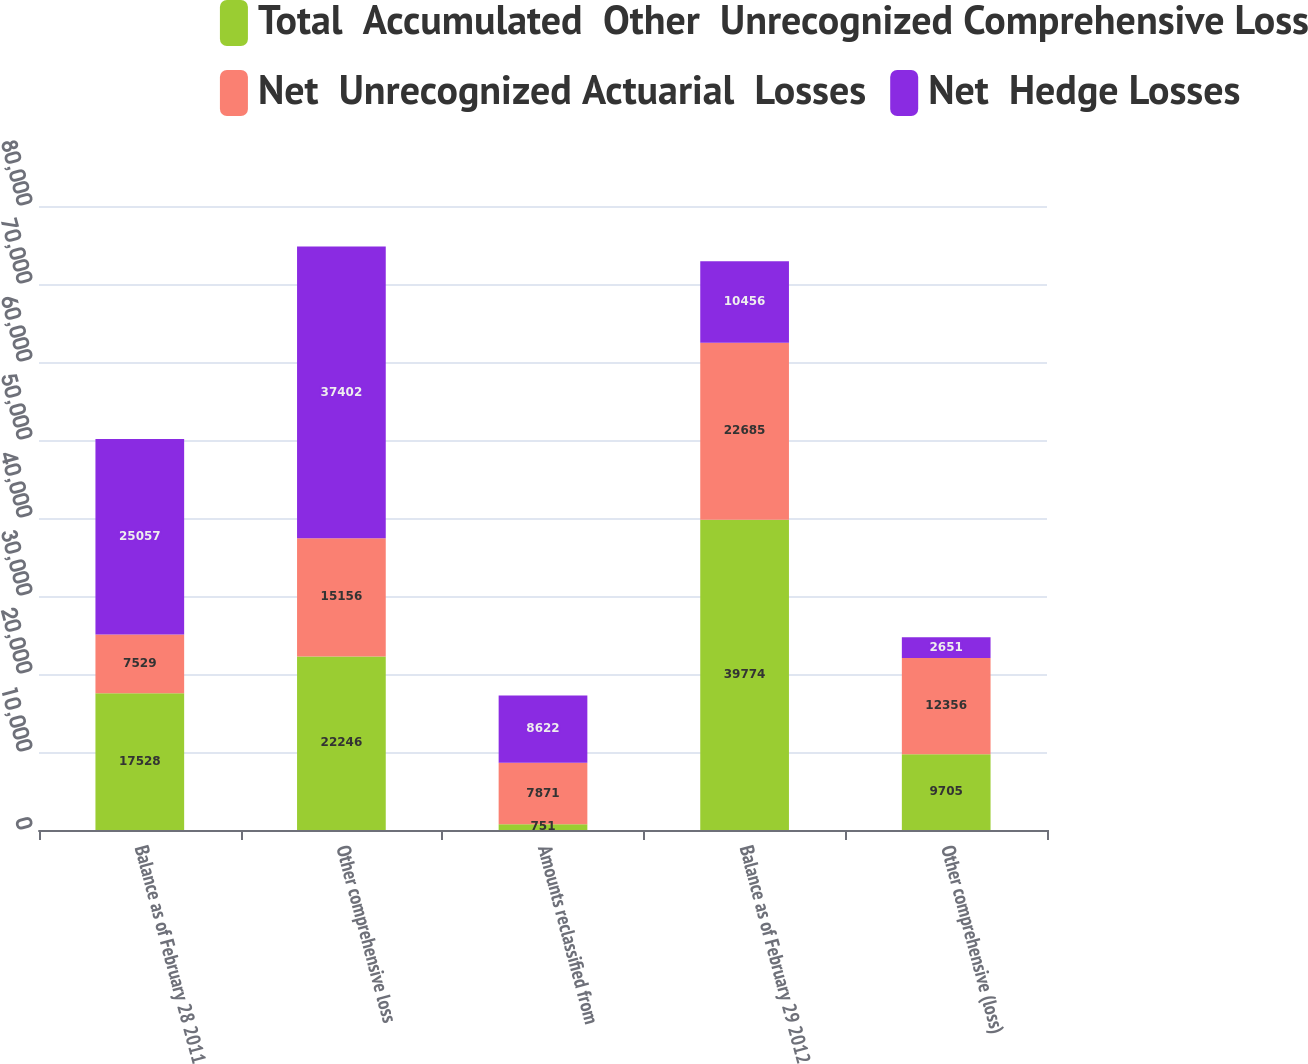Convert chart. <chart><loc_0><loc_0><loc_500><loc_500><stacked_bar_chart><ecel><fcel>Balance as of February 28 2011<fcel>Other comprehensive loss<fcel>Amounts reclassified from<fcel>Balance as of February 29 2012<fcel>Other comprehensive (loss)<nl><fcel>Total  Accumulated  Other  Unrecognized Comprehensive Loss<fcel>17528<fcel>22246<fcel>751<fcel>39774<fcel>9705<nl><fcel>Net  Unrecognized Actuarial  Losses<fcel>7529<fcel>15156<fcel>7871<fcel>22685<fcel>12356<nl><fcel>Net  Hedge Losses<fcel>25057<fcel>37402<fcel>8622<fcel>10456<fcel>2651<nl></chart> 